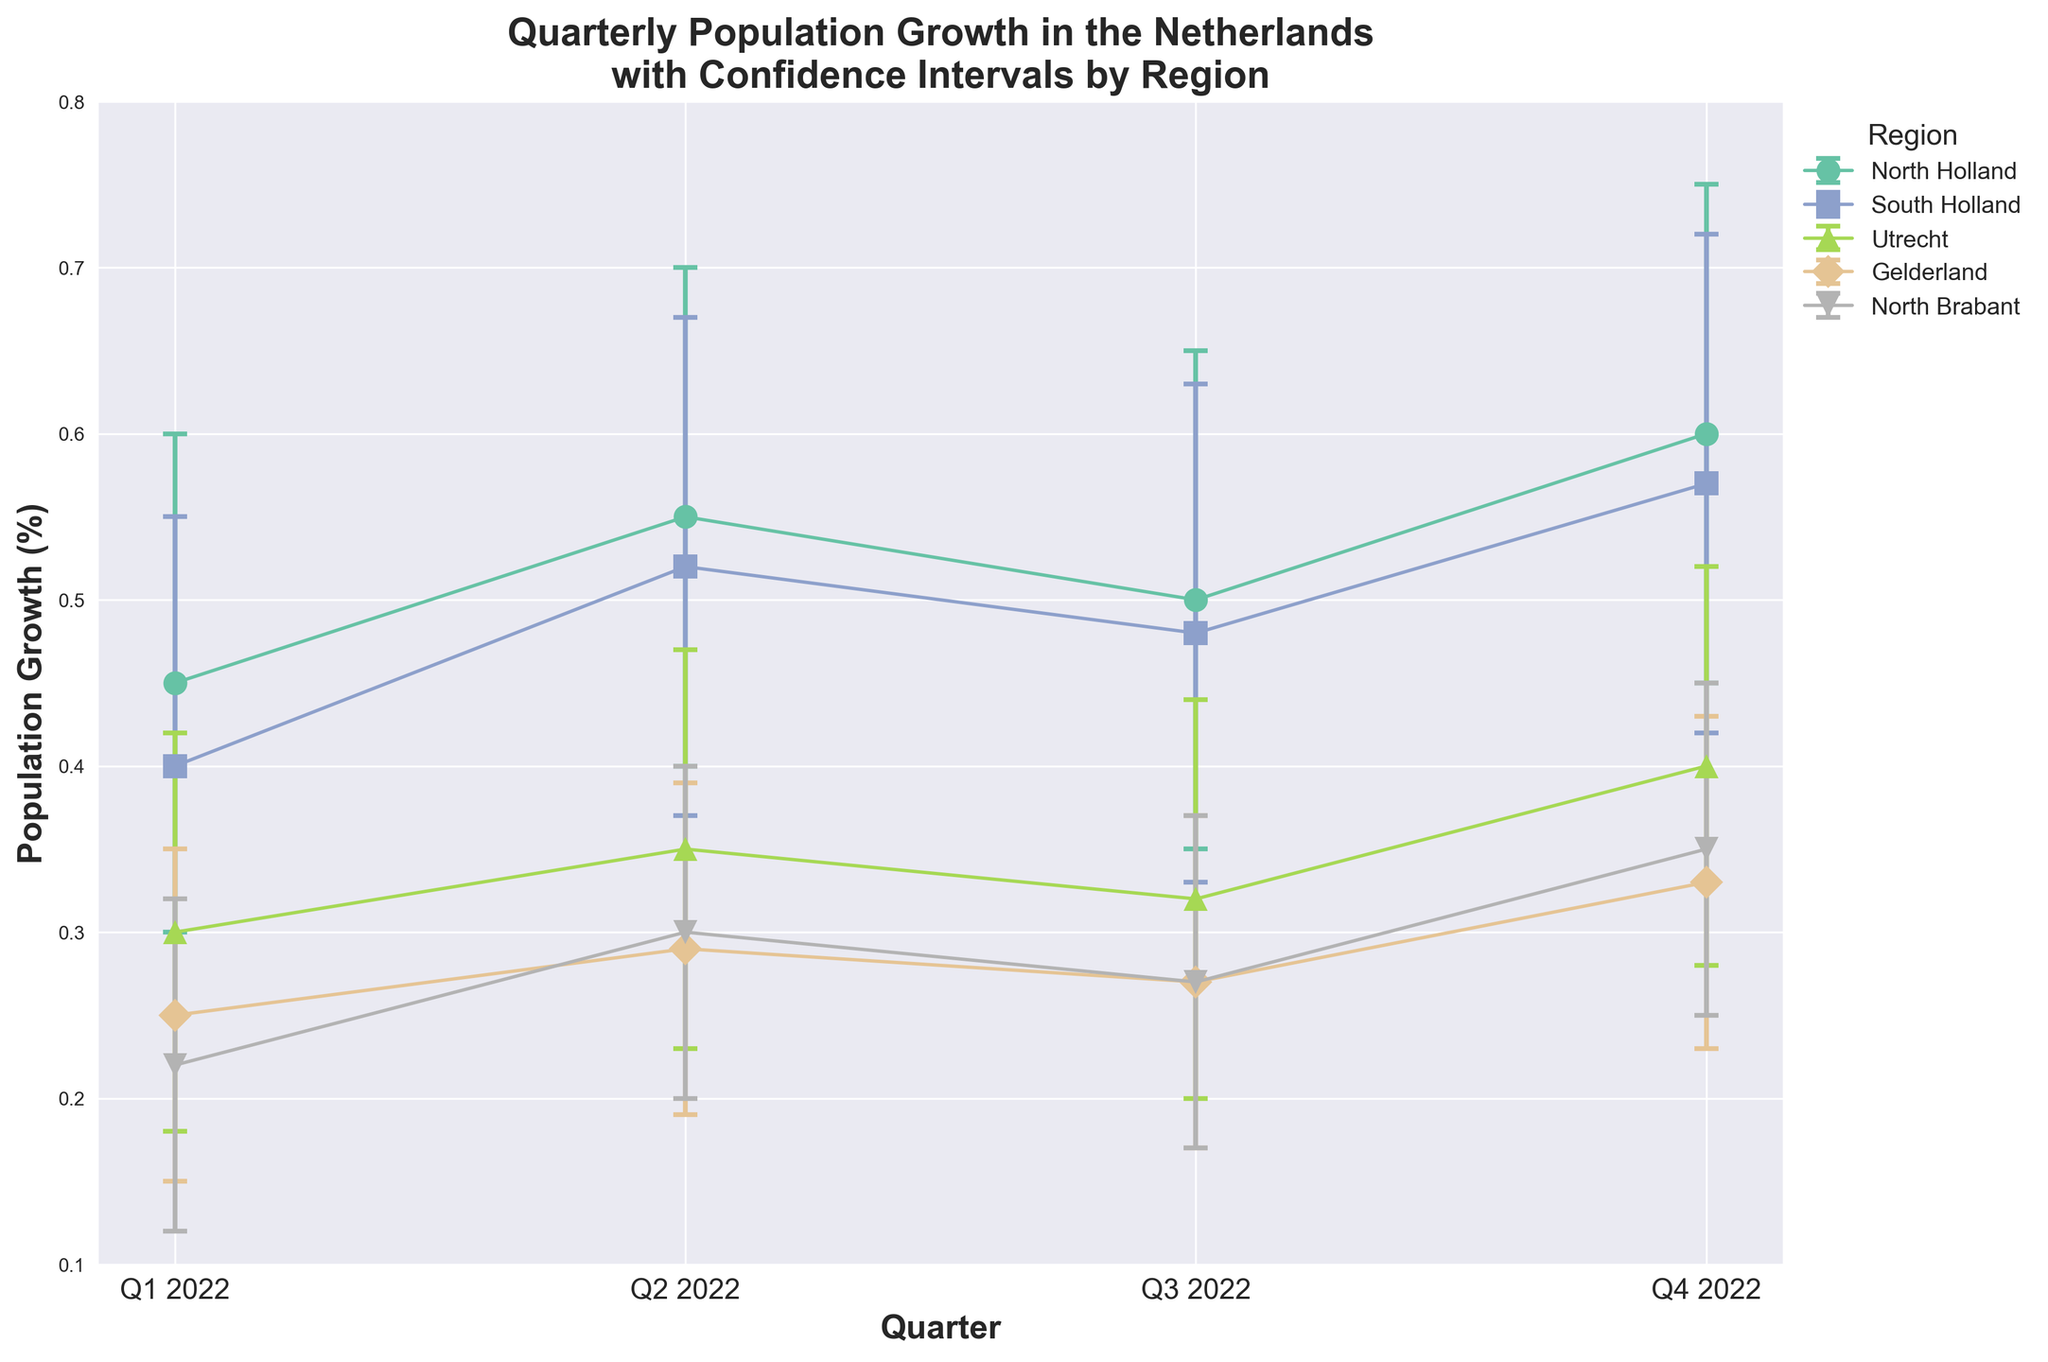What is the population growth percentage for North Holland in Q1 2022? The plot shows the population growth percentage values per quarter for each region. For North Holland in Q1 2022, the data point is at 0.45.
Answer: 0.45 Which region shows the highest population growth percentage in Q2 2022? By comparing the heights of the data points for Q2 2022, we see that North Holland has the highest population growth percentage at 0.55.
Answer: North Holland What is the general trend in population growth for South Holland over the quarters in 2022? Observing the error bars for South Holland, the population growth generally increases from Q1 (0.40) to Q4 (0.57).
Answer: Increasing How does the range of the error bars compare between Q1 2022 and Q4 2022 for Utrecht? In Q1 2022, the range is from 0.18 to 0.42 (0.24) while in Q4 2022, it is from 0.28 to 0.52 (0.24), showing that the range remains consistent.
Answer: Consistent Which quarter has the smallest population growth variance for Gelderland? The population growth variance can be observed through the error bars. In Q1 2022, the error bar range is narrowest (0.15 to 0.35), indicating the smallest variance.
Answer: Q1 2022 For North Brabant, how does the population growth in Q2 2022 compare to Q3 2022? Comparing the values, we see that the population growth increases from 0.30 in Q2 2022 to 0.27 in Q3 2022.
Answer: Decreases What is the average population growth for Utrecht across all quarters in 2022? The population growth percentages for Utrecht are 0.30, 0.35, 0.32, and 0.40. The average is (0.30 + 0.35 + 0.32 + 0.40) / 4 = 0.3425.
Answer: 0.3425 Which region has the highest overall population growth for 2022, and what is the value? By adding up the population growth for each region, North Holland's total (0.45+0.55+0.50+0.60) equals 2.10, which is the highest.
Answer: North Holland, 2.10 How do the confidence intervals for North Holland in Q3 2022 compare to those in Q4 2022? In Q3 2022, the confidence interval is (0.35 to 0.65), and in Q4 2022, it is (0.45 to 0.75). Both intervals are equal in range (0.30), but Q4 2022 shifts higher.
Answer: Q4 2022 shifts higher What can be said about the trend and reliability of North Brabant's population growth throughout 2022? The trend shows an increase from Q1 (0.22) to Q4 (0.35), while the consistent confidence intervals indicate steady reliability in the measurements.
Answer: Increasing with steady reliability 